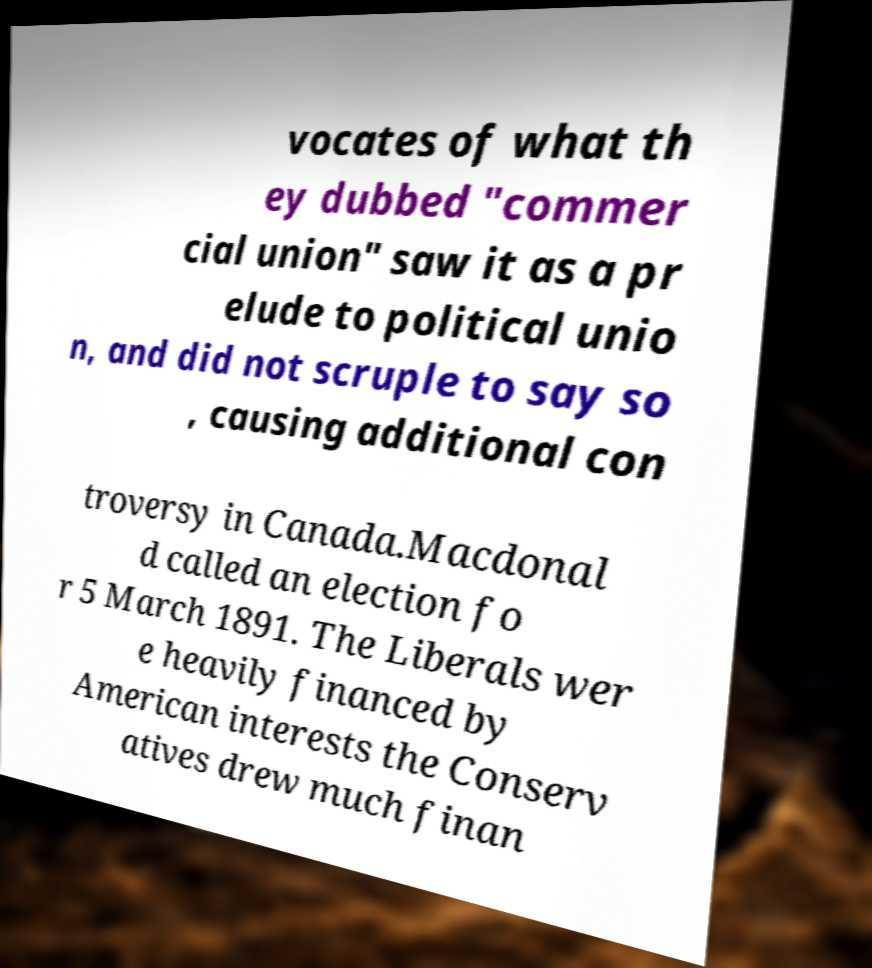For documentation purposes, I need the text within this image transcribed. Could you provide that? vocates of what th ey dubbed "commer cial union" saw it as a pr elude to political unio n, and did not scruple to say so , causing additional con troversy in Canada.Macdonal d called an election fo r 5 March 1891. The Liberals wer e heavily financed by American interests the Conserv atives drew much finan 